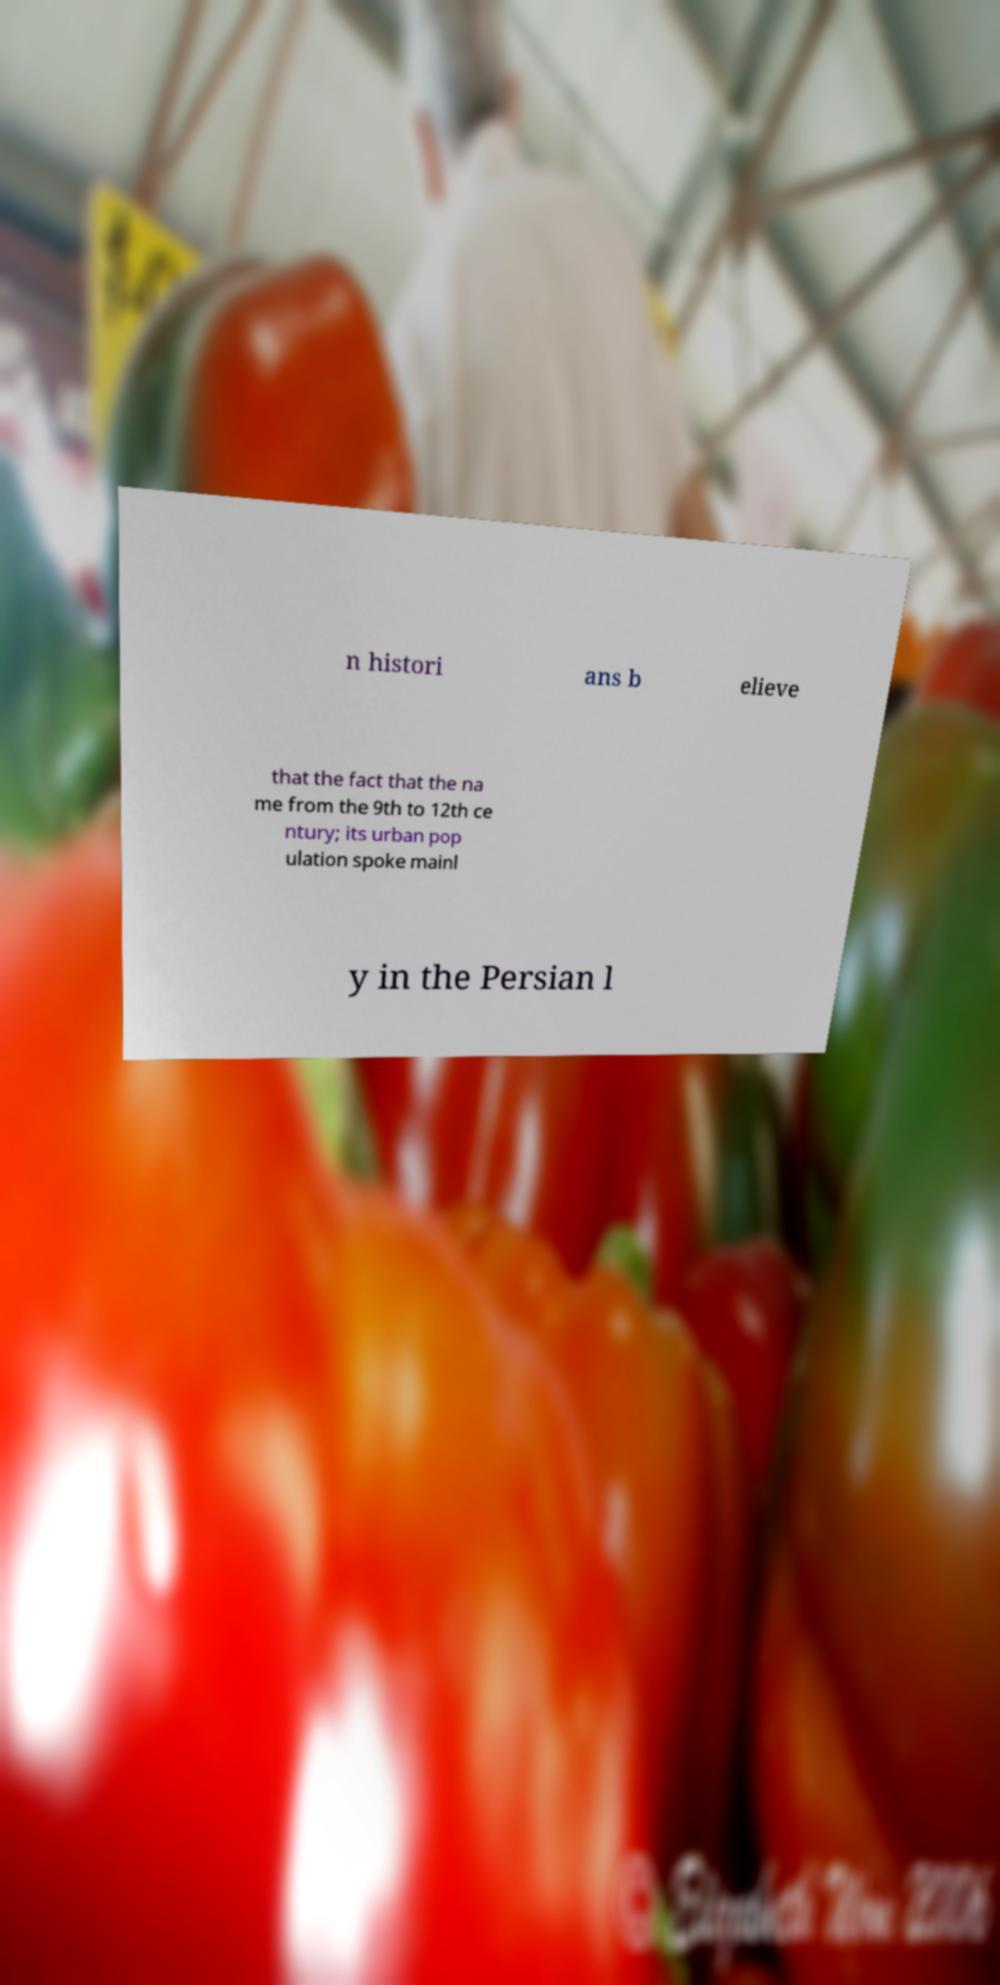Can you read and provide the text displayed in the image?This photo seems to have some interesting text. Can you extract and type it out for me? n histori ans b elieve that the fact that the na me from the 9th to 12th ce ntury; its urban pop ulation spoke mainl y in the Persian l 